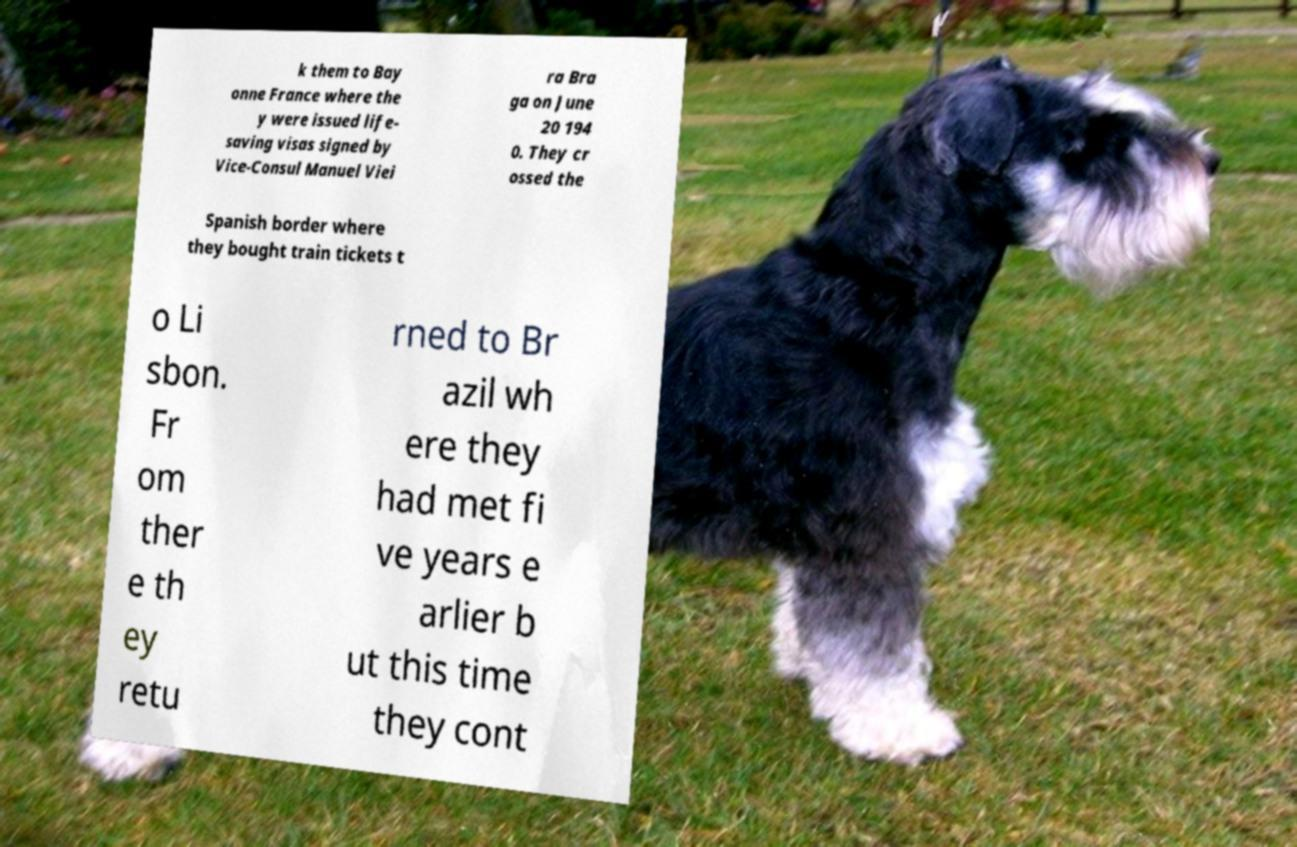Can you read and provide the text displayed in the image?This photo seems to have some interesting text. Can you extract and type it out for me? k them to Bay onne France where the y were issued life- saving visas signed by Vice-Consul Manuel Viei ra Bra ga on June 20 194 0. They cr ossed the Spanish border where they bought train tickets t o Li sbon. Fr om ther e th ey retu rned to Br azil wh ere they had met fi ve years e arlier b ut this time they cont 